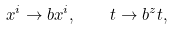<formula> <loc_0><loc_0><loc_500><loc_500>x ^ { i } \rightarrow b x ^ { i } , \quad t \rightarrow b ^ { z } t ,</formula> 